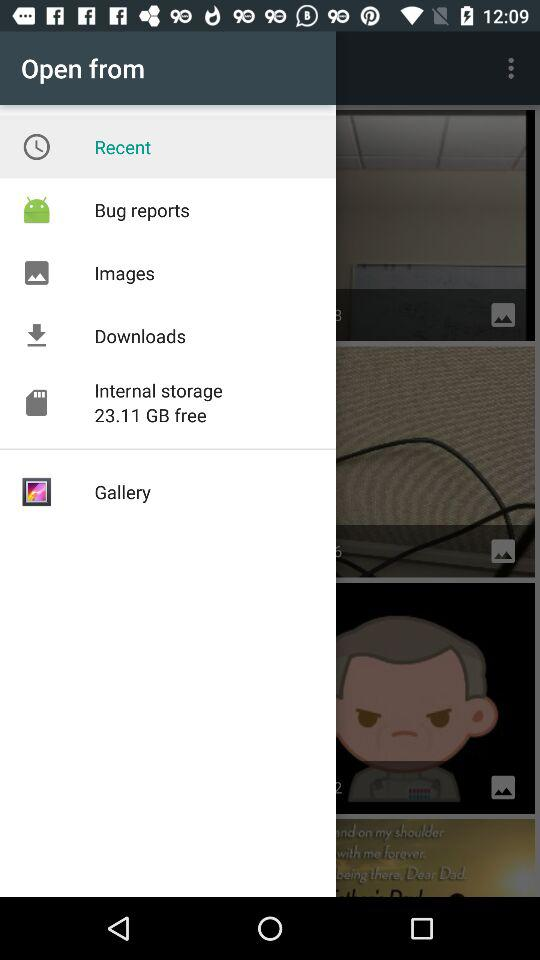What option is selected? The selected option is recent. 